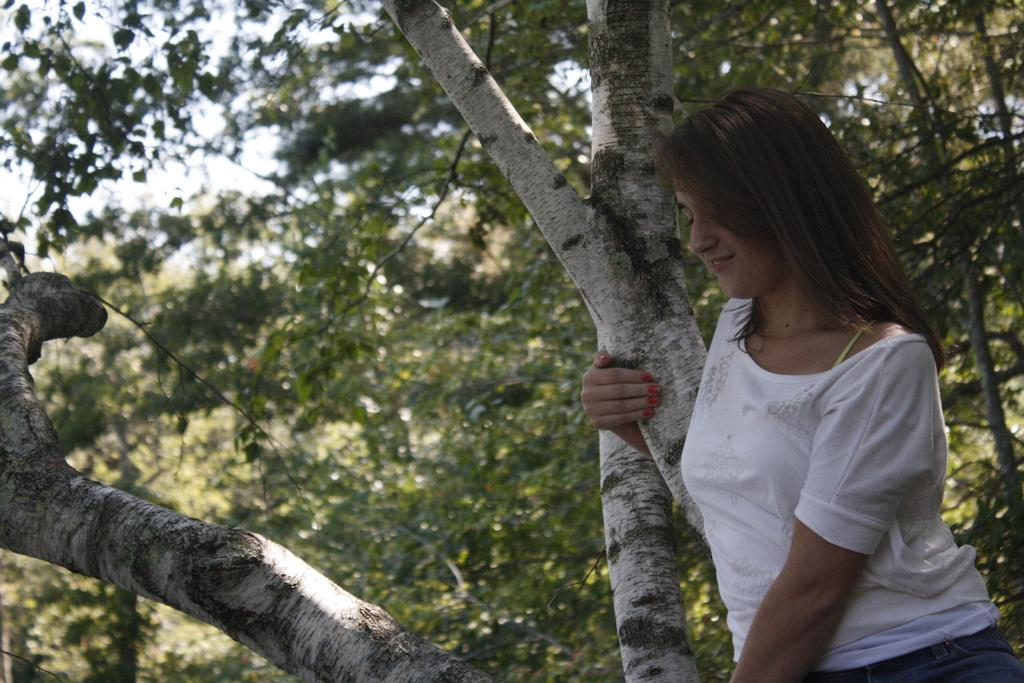What is the main subject of the image? There is a woman standing in the image. What is the woman holding in the image? The woman is holding a tree trunk. What can be seen in the background of the image? There are trees visible in the background of the image. How would you describe the background of the image? The background of the image is slightly blurred. What type of jelly can be seen on the hill in the image? There is no jelly or hill present in the image. Is there a house visible in the image? The provided facts do not mention a house, so we cannot determine if one is present in the image. 